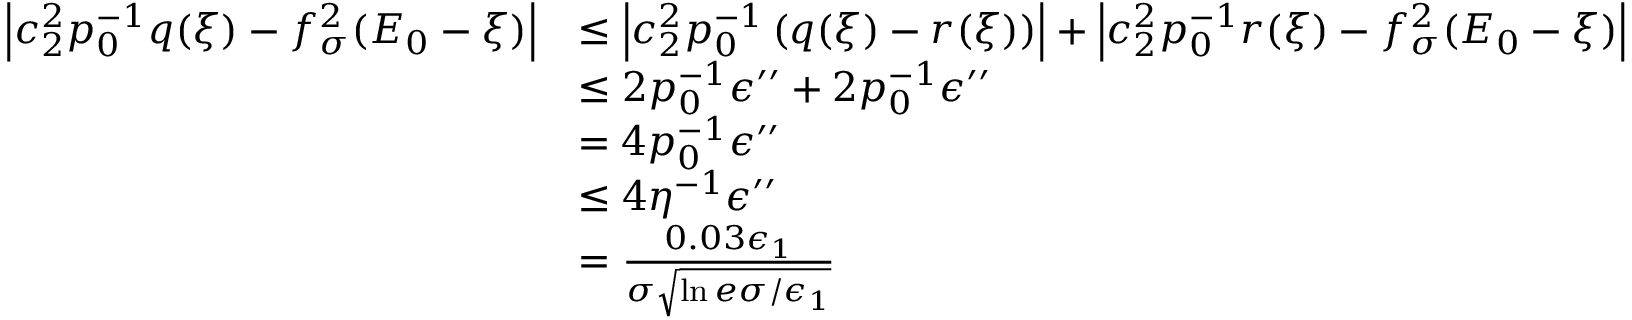Convert formula to latex. <formula><loc_0><loc_0><loc_500><loc_500>\begin{array} { r l } { \left | c _ { 2 } ^ { 2 } p _ { 0 } ^ { - 1 } q ( \xi ) - f _ { \sigma } ^ { 2 } ( E _ { 0 } - \xi ) \right | } & { \leq \left | c _ { 2 } ^ { 2 } p _ { 0 } ^ { - 1 } \left ( q ( \xi ) - r ( \xi ) \right ) \right | + \left | c _ { 2 } ^ { 2 } p _ { 0 } ^ { - 1 } r ( \xi ) - f _ { \sigma } ^ { 2 } ( E _ { 0 } - \xi ) \right | } \\ & { \leq 2 p _ { 0 } ^ { - 1 } \epsilon ^ { \prime \prime } + 2 p _ { 0 } ^ { - 1 } \epsilon ^ { \prime \prime } } \\ & { = 4 p _ { 0 } ^ { - 1 } \epsilon ^ { \prime \prime } } \\ & { \leq 4 \eta ^ { - 1 } \epsilon ^ { \prime \prime } } \\ & { = \frac { 0 . 0 3 \epsilon _ { 1 } } { \sigma \sqrt { \ln { e \sigma / \epsilon _ { 1 } } } } } \end{array}</formula> 